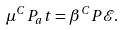<formula> <loc_0><loc_0><loc_500><loc_500>\mu ^ { C } P _ { a } t = \beta ^ { C } P \mathcal { E } .</formula> 